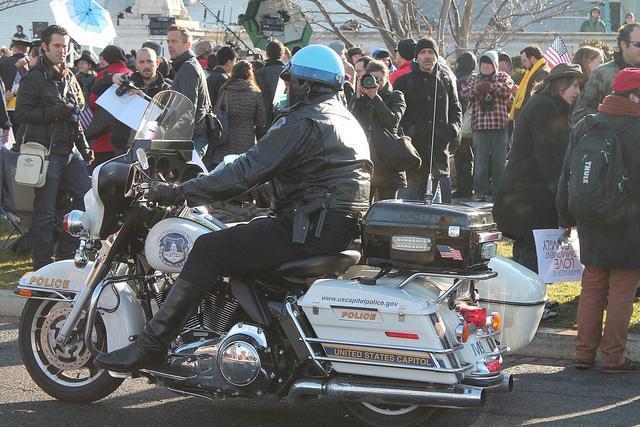How many people are in the picture?
Give a very brief answer. 10. How many umbrellas can be seen?
Give a very brief answer. 2. 